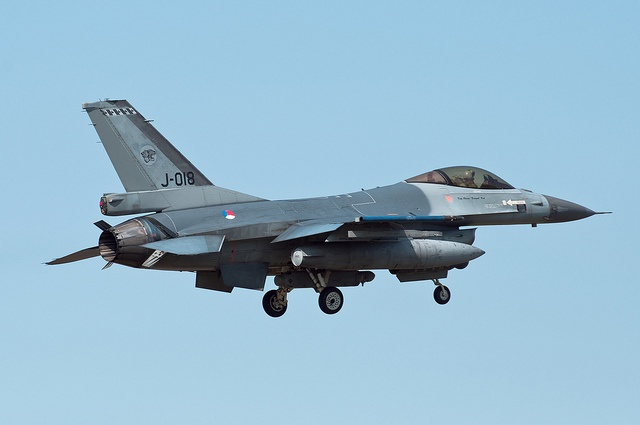Describe the objects in this image and their specific colors. I can see airplane in lightblue, black, and gray tones and people in lightblue, gray, and black tones in this image. 